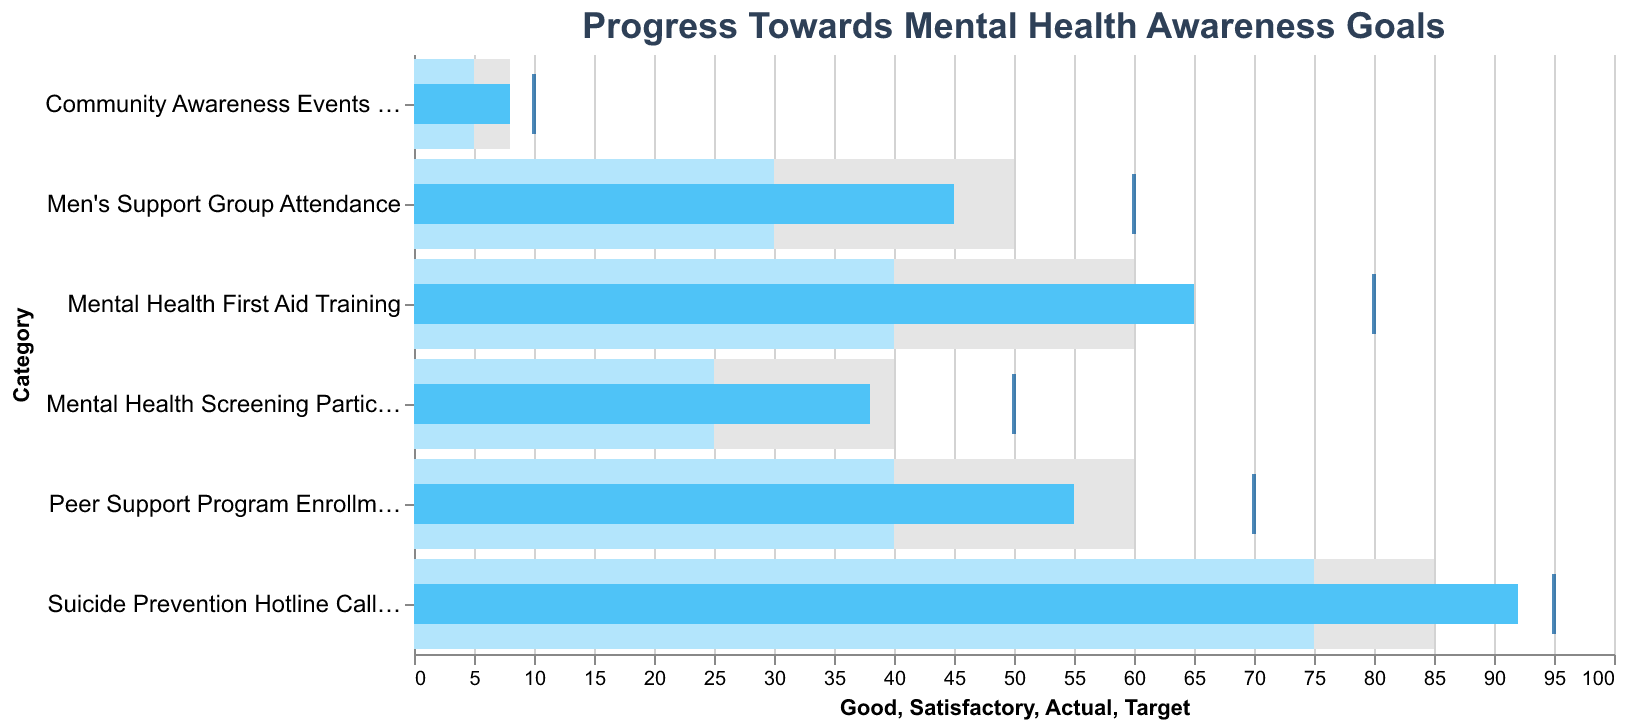What is the title of the figure? The title is typically found at the top of the figure and provides a concise description of what the figure represents.
Answer: Progress Towards Mental Health Awareness Goals How many categories are shown in the figure? Count the unique categories listed on the y-axis.
Answer: 6 What is the actual value for Men's Support Group Attendance? Look for the darker blue bar corresponding to the "Men's Support Group Attendance" category.
Answer: 45 Which category has the highest actual value? Compare the heights of the darker blue bars to see which one is the tallest.
Answer: Suicide Prevention Hotline Calls Answered What is the target value for Mental Health First Aid Training? Look for the small tick mark next to the "Mental Health First Aid Training " category at the top of the y-axis and note its corresponding value.
Answer: 80 Are there any categories where the actual value exceeds the target value? Compare the darker blue bar values to the corresponding tick marks for each category.
Answer: No What is the difference between the actual and target values for Peer Support Program Enrollment? Subtract the actual value from the target value for "Peer Support Program Enrollment" (70 - 55).
Answer: 15 Which program has the smallest gap between actual and target values? Calculate the difference between actual and target values for all categories, then identify which is the smallest. (Suicide Prevention Hotline Calls Answered: 95 - 92 = 3)
Answer: Suicide Prevention Hotline Calls Answered Which categories have met the "Good" performance range? Determine which categories have their actual values (darker blue bars) equal to or greater than the "Good" performance values (lightest gray bar end). (Mental Health First Aid Training: 65 ≥ 60; Suicide Prevention Hotline Calls Answered: 92 ≥ 85; Community Awareness Events Held: 8 ≥ 8)
Answer: Mental Health First Aid Training, Suicide Prevention Hotline Calls Answered, Community Awareness Events Held 